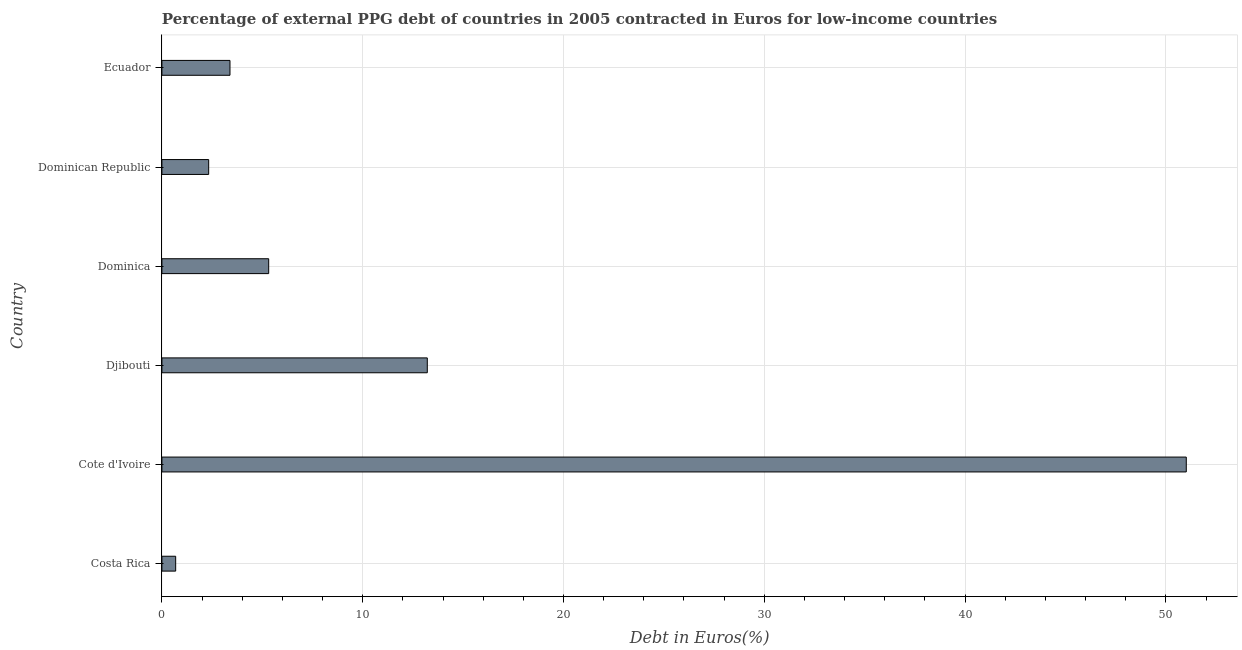Does the graph contain any zero values?
Your answer should be very brief. No. Does the graph contain grids?
Offer a terse response. Yes. What is the title of the graph?
Your answer should be very brief. Percentage of external PPG debt of countries in 2005 contracted in Euros for low-income countries. What is the label or title of the X-axis?
Offer a terse response. Debt in Euros(%). What is the label or title of the Y-axis?
Ensure brevity in your answer.  Country. What is the currency composition of ppg debt in Costa Rica?
Ensure brevity in your answer.  0.69. Across all countries, what is the maximum currency composition of ppg debt?
Make the answer very short. 51.02. Across all countries, what is the minimum currency composition of ppg debt?
Your answer should be very brief. 0.69. In which country was the currency composition of ppg debt maximum?
Your answer should be very brief. Cote d'Ivoire. What is the sum of the currency composition of ppg debt?
Your answer should be compact. 75.96. What is the difference between the currency composition of ppg debt in Costa Rica and Cote d'Ivoire?
Offer a terse response. -50.33. What is the average currency composition of ppg debt per country?
Give a very brief answer. 12.66. What is the median currency composition of ppg debt?
Offer a terse response. 4.35. What is the ratio of the currency composition of ppg debt in Djibouti to that in Dominica?
Provide a short and direct response. 2.48. Is the difference between the currency composition of ppg debt in Costa Rica and Dominican Republic greater than the difference between any two countries?
Your answer should be very brief. No. What is the difference between the highest and the second highest currency composition of ppg debt?
Your answer should be compact. 37.8. Is the sum of the currency composition of ppg debt in Djibouti and Ecuador greater than the maximum currency composition of ppg debt across all countries?
Provide a short and direct response. No. What is the difference between the highest and the lowest currency composition of ppg debt?
Ensure brevity in your answer.  50.33. In how many countries, is the currency composition of ppg debt greater than the average currency composition of ppg debt taken over all countries?
Provide a succinct answer. 2. How many bars are there?
Offer a very short reply. 6. Are all the bars in the graph horizontal?
Keep it short and to the point. Yes. How many countries are there in the graph?
Ensure brevity in your answer.  6. What is the Debt in Euros(%) in Costa Rica?
Your answer should be very brief. 0.69. What is the Debt in Euros(%) of Cote d'Ivoire?
Make the answer very short. 51.02. What is the Debt in Euros(%) in Djibouti?
Provide a short and direct response. 13.22. What is the Debt in Euros(%) in Dominica?
Your answer should be very brief. 5.32. What is the Debt in Euros(%) of Dominican Republic?
Your answer should be very brief. 2.33. What is the Debt in Euros(%) of Ecuador?
Provide a succinct answer. 3.39. What is the difference between the Debt in Euros(%) in Costa Rica and Cote d'Ivoire?
Provide a succinct answer. -50.33. What is the difference between the Debt in Euros(%) in Costa Rica and Djibouti?
Ensure brevity in your answer.  -12.53. What is the difference between the Debt in Euros(%) in Costa Rica and Dominica?
Offer a very short reply. -4.63. What is the difference between the Debt in Euros(%) in Costa Rica and Dominican Republic?
Provide a succinct answer. -1.64. What is the difference between the Debt in Euros(%) in Costa Rica and Ecuador?
Offer a terse response. -2.71. What is the difference between the Debt in Euros(%) in Cote d'Ivoire and Djibouti?
Ensure brevity in your answer.  37.8. What is the difference between the Debt in Euros(%) in Cote d'Ivoire and Dominica?
Give a very brief answer. 45.7. What is the difference between the Debt in Euros(%) in Cote d'Ivoire and Dominican Republic?
Provide a short and direct response. 48.69. What is the difference between the Debt in Euros(%) in Cote d'Ivoire and Ecuador?
Keep it short and to the point. 47.62. What is the difference between the Debt in Euros(%) in Djibouti and Dominica?
Give a very brief answer. 7.9. What is the difference between the Debt in Euros(%) in Djibouti and Dominican Republic?
Make the answer very short. 10.89. What is the difference between the Debt in Euros(%) in Djibouti and Ecuador?
Provide a succinct answer. 9.83. What is the difference between the Debt in Euros(%) in Dominica and Dominican Republic?
Provide a short and direct response. 2.99. What is the difference between the Debt in Euros(%) in Dominica and Ecuador?
Ensure brevity in your answer.  1.93. What is the difference between the Debt in Euros(%) in Dominican Republic and Ecuador?
Offer a very short reply. -1.06. What is the ratio of the Debt in Euros(%) in Costa Rica to that in Cote d'Ivoire?
Keep it short and to the point. 0.01. What is the ratio of the Debt in Euros(%) in Costa Rica to that in Djibouti?
Your answer should be very brief. 0.05. What is the ratio of the Debt in Euros(%) in Costa Rica to that in Dominica?
Offer a very short reply. 0.13. What is the ratio of the Debt in Euros(%) in Costa Rica to that in Dominican Republic?
Ensure brevity in your answer.  0.29. What is the ratio of the Debt in Euros(%) in Costa Rica to that in Ecuador?
Offer a very short reply. 0.2. What is the ratio of the Debt in Euros(%) in Cote d'Ivoire to that in Djibouti?
Give a very brief answer. 3.86. What is the ratio of the Debt in Euros(%) in Cote d'Ivoire to that in Dominica?
Make the answer very short. 9.59. What is the ratio of the Debt in Euros(%) in Cote d'Ivoire to that in Dominican Republic?
Your response must be concise. 21.9. What is the ratio of the Debt in Euros(%) in Cote d'Ivoire to that in Ecuador?
Provide a succinct answer. 15.04. What is the ratio of the Debt in Euros(%) in Djibouti to that in Dominica?
Your answer should be compact. 2.48. What is the ratio of the Debt in Euros(%) in Djibouti to that in Dominican Republic?
Ensure brevity in your answer.  5.67. What is the ratio of the Debt in Euros(%) in Djibouti to that in Ecuador?
Offer a terse response. 3.9. What is the ratio of the Debt in Euros(%) in Dominica to that in Dominican Republic?
Keep it short and to the point. 2.28. What is the ratio of the Debt in Euros(%) in Dominica to that in Ecuador?
Provide a short and direct response. 1.57. What is the ratio of the Debt in Euros(%) in Dominican Republic to that in Ecuador?
Your answer should be very brief. 0.69. 